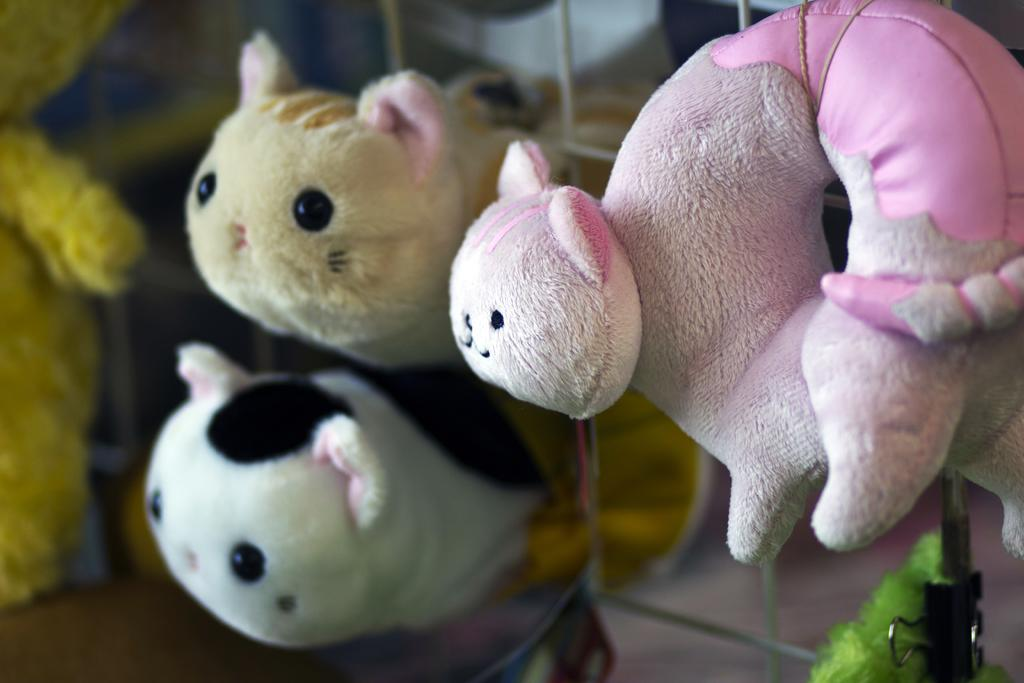What type of objects can be seen in the image? There are toys in the image. What type of boundary is depicted in the image? There is no boundary depicted in the image; it features toys. What color is the sweater worn by the toy in the image? There is no toy wearing a sweater in the image, as it only features toys in general. 